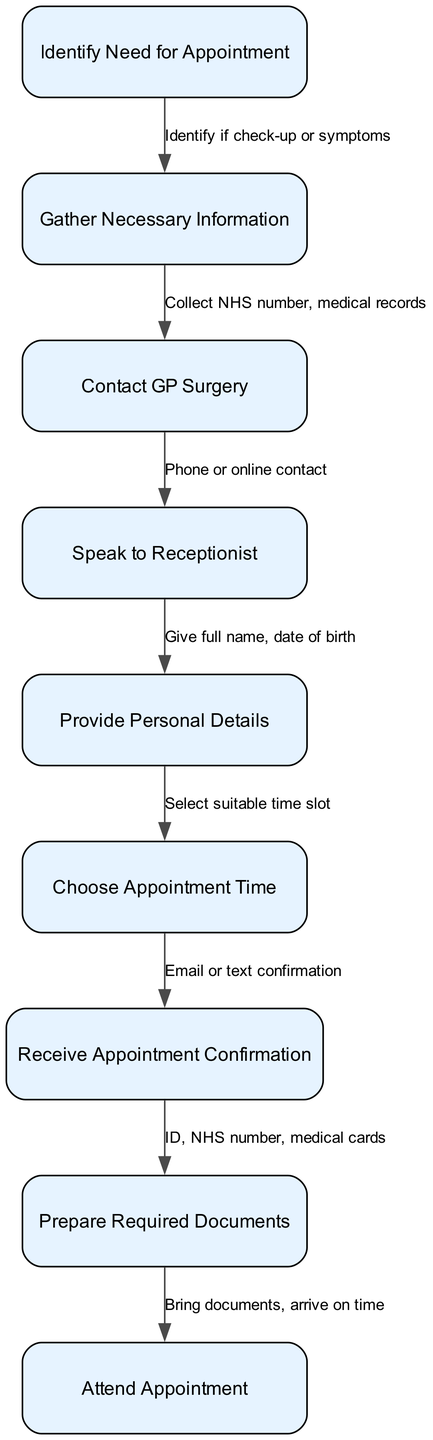What is the first step in booking a medical appointment? The first step in the process is labeled "Identify Need for Appointment." This node starts the flow of actions needed to result in a booked appointment.
Answer: Identify Need for Appointment How many nodes are present in the diagram? By counting all the distinct actions or states defined in the nodes section, we find that there are nine nodes in total.
Answer: 9 What information do you need to gather before contacting the GP surgery? The diagram indicates that necessary information consists of collecting the NHS number and medical records. This step prepares for initiating contact with the GP surgery.
Answer: NHS number, medical records What happens after you receive appointment confirmation? Following the "Receive Appointment Confirmation," the next step is to "Prepare Required Documents," which indicates the need to gather essential items necessary for the appointment.
Answer: Prepare Required Documents Which step involves speaking to the receptionist? The step titled "Speak to Receptionist" specifically involves the interaction with the receptionist either through phone or online contact, as described in the diagram.
Answer: Speak to Receptionist What are the required documents to prepare? According to the diagram, the documents needed include ID, NHS number, and medical cards, which are essential for attending the appointment.
Answer: ID, NHS number, medical cards What action follows the selection of a suitable time slot? Once you have selected a suitable time slot, the next action in the diagram is receiving an appointment confirmation via email or text message.
Answer: Receive Appointment Confirmation How do you initiate contact with the GP surgery? The diagram states that contact with the GP surgery can be made either by phone or through online methods, which both serve as means to get in touch with the surgery.
Answer: Phone or online contact What must you do with your documents before going to the appointment? Prior to attending the appointment, you need to bring the prepared documents and ensure you arrive on time, as indicated in the final steps of the diagram.
Answer: Bring documents, arrive on time 